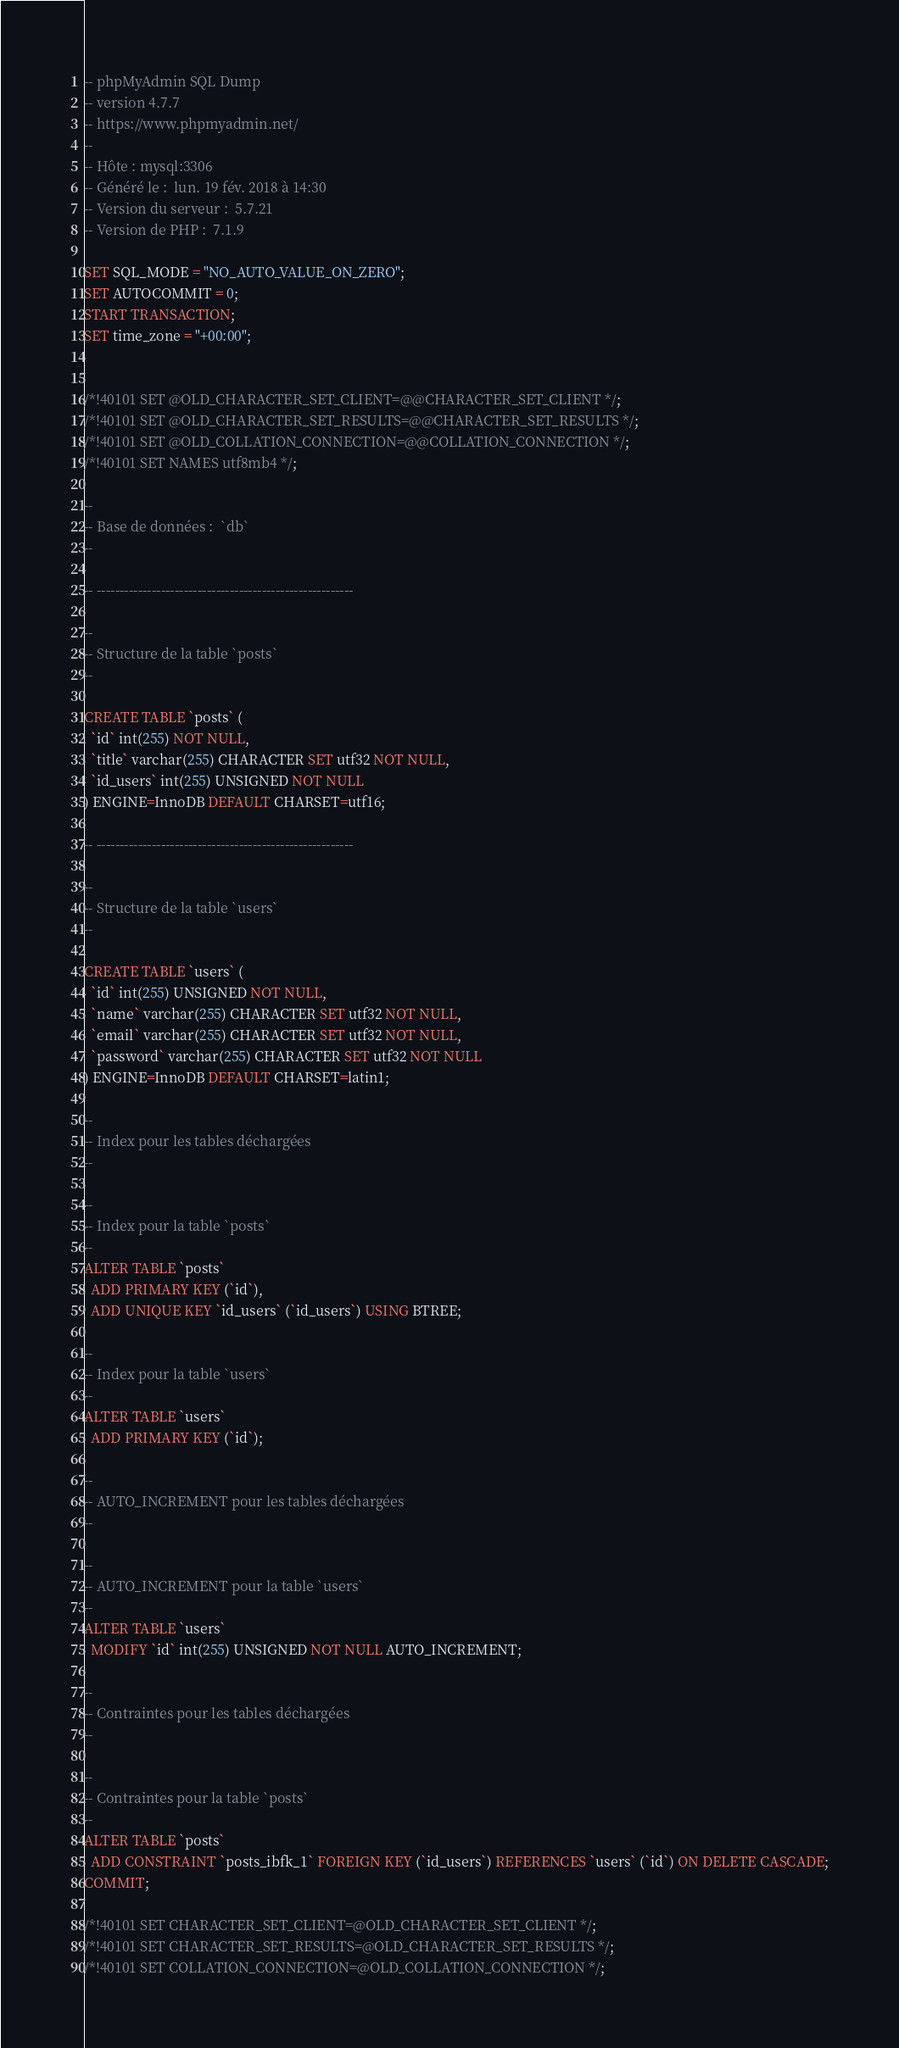Convert code to text. <code><loc_0><loc_0><loc_500><loc_500><_SQL_>-- phpMyAdmin SQL Dump
-- version 4.7.7
-- https://www.phpmyadmin.net/
--
-- Hôte : mysql:3306
-- Généré le :  lun. 19 fév. 2018 à 14:30
-- Version du serveur :  5.7.21
-- Version de PHP :  7.1.9

SET SQL_MODE = "NO_AUTO_VALUE_ON_ZERO";
SET AUTOCOMMIT = 0;
START TRANSACTION;
SET time_zone = "+00:00";


/*!40101 SET @OLD_CHARACTER_SET_CLIENT=@@CHARACTER_SET_CLIENT */;
/*!40101 SET @OLD_CHARACTER_SET_RESULTS=@@CHARACTER_SET_RESULTS */;
/*!40101 SET @OLD_COLLATION_CONNECTION=@@COLLATION_CONNECTION */;
/*!40101 SET NAMES utf8mb4 */;

--
-- Base de données :  `db`
--

-- --------------------------------------------------------

--
-- Structure de la table `posts`
--

CREATE TABLE `posts` (
  `id` int(255) NOT NULL,
  `title` varchar(255) CHARACTER SET utf32 NOT NULL,
  `id_users` int(255) UNSIGNED NOT NULL
) ENGINE=InnoDB DEFAULT CHARSET=utf16;

-- --------------------------------------------------------

--
-- Structure de la table `users`
--

CREATE TABLE `users` (
  `id` int(255) UNSIGNED NOT NULL,
  `name` varchar(255) CHARACTER SET utf32 NOT NULL,
  `email` varchar(255) CHARACTER SET utf32 NOT NULL,
  `password` varchar(255) CHARACTER SET utf32 NOT NULL
) ENGINE=InnoDB DEFAULT CHARSET=latin1;

--
-- Index pour les tables déchargées
--

--
-- Index pour la table `posts`
--
ALTER TABLE `posts`
  ADD PRIMARY KEY (`id`),
  ADD UNIQUE KEY `id_users` (`id_users`) USING BTREE;

--
-- Index pour la table `users`
--
ALTER TABLE `users`
  ADD PRIMARY KEY (`id`);

--
-- AUTO_INCREMENT pour les tables déchargées
--

--
-- AUTO_INCREMENT pour la table `users`
--
ALTER TABLE `users`
  MODIFY `id` int(255) UNSIGNED NOT NULL AUTO_INCREMENT;

--
-- Contraintes pour les tables déchargées
--

--
-- Contraintes pour la table `posts`
--
ALTER TABLE `posts`
  ADD CONSTRAINT `posts_ibfk_1` FOREIGN KEY (`id_users`) REFERENCES `users` (`id`) ON DELETE CASCADE;
COMMIT;

/*!40101 SET CHARACTER_SET_CLIENT=@OLD_CHARACTER_SET_CLIENT */;
/*!40101 SET CHARACTER_SET_RESULTS=@OLD_CHARACTER_SET_RESULTS */;
/*!40101 SET COLLATION_CONNECTION=@OLD_COLLATION_CONNECTION */;
</code> 